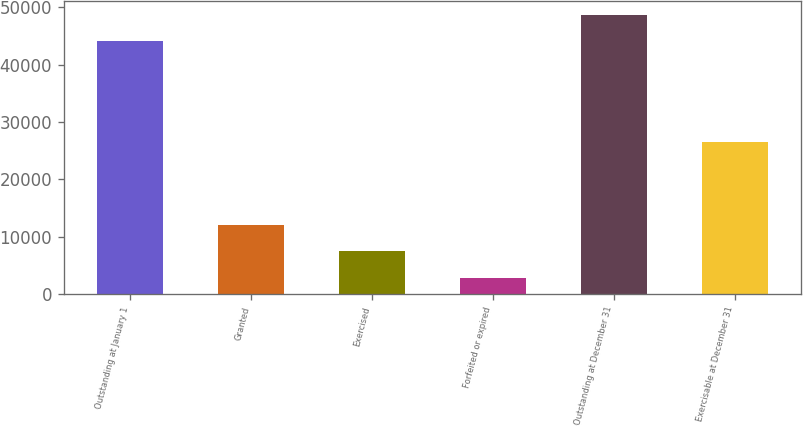<chart> <loc_0><loc_0><loc_500><loc_500><bar_chart><fcel>Outstanding at January 1<fcel>Granted<fcel>Exercised<fcel>Forfeited or expired<fcel>Outstanding at December 31<fcel>Exercisable at December 31<nl><fcel>44120<fcel>12027<fcel>7455.5<fcel>2884<fcel>48691.5<fcel>26462<nl></chart> 